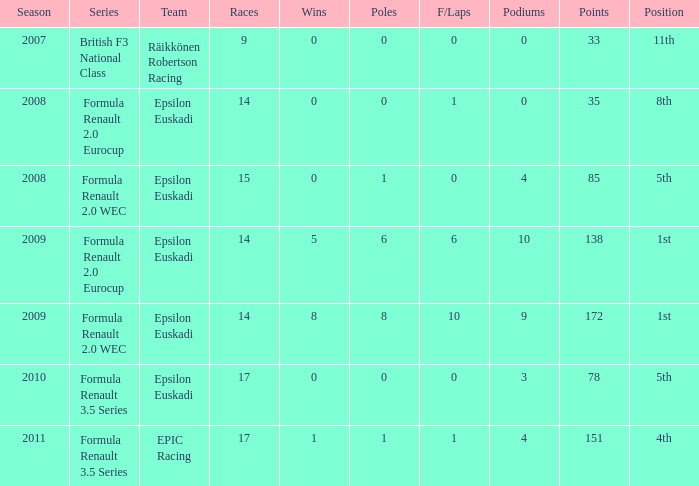Help me parse the entirety of this table. {'header': ['Season', 'Series', 'Team', 'Races', 'Wins', 'Poles', 'F/Laps', 'Podiums', 'Points', 'Position'], 'rows': [['2007', 'British F3 National Class', 'Räikkönen Robertson Racing', '9', '0', '0', '0', '0', '33', '11th'], ['2008', 'Formula Renault 2.0 Eurocup', 'Epsilon Euskadi', '14', '0', '0', '1', '0', '35', '8th'], ['2008', 'Formula Renault 2.0 WEC', 'Epsilon Euskadi', '15', '0', '1', '0', '4', '85', '5th'], ['2009', 'Formula Renault 2.0 Eurocup', 'Epsilon Euskadi', '14', '5', '6', '6', '10', '138', '1st'], ['2009', 'Formula Renault 2.0 WEC', 'Epsilon Euskadi', '14', '8', '8', '10', '9', '172', '1st'], ['2010', 'Formula Renault 3.5 Series', 'Epsilon Euskadi', '17', '0', '0', '0', '3', '78', '5th'], ['2011', 'Formula Renault 3.5 Series', 'EPIC Racing', '17', '1', '1', '1', '4', '151', '4th']]} What group was he in when he completed in 11th rank? Räikkönen Robertson Racing. 